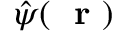Convert formula to latex. <formula><loc_0><loc_0><loc_500><loc_500>\hat { \psi } ( r )</formula> 